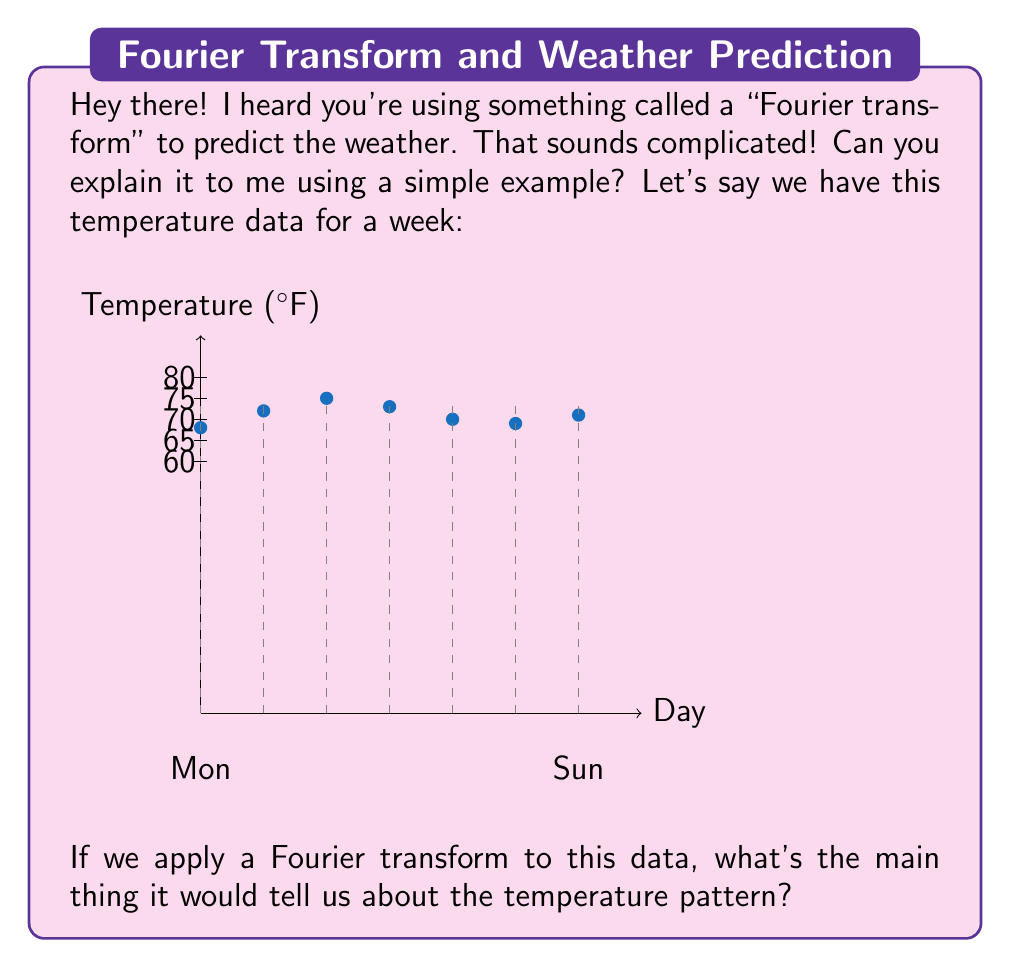Can you solve this math problem? Great question! I'd be happy to explain this in simple terms.

1) First, let's understand what the Fourier transform does. It breaks down a complex pattern into simpler, repeating waves.

2) In our temperature data, we see the temperature goes up and down over the week. The Fourier transform would look for repeating patterns in this up-and-down movement.

3) The main thing the Fourier transform would show us is the most dominant cycle in the data. In weather terms, this is often called the "period" of the pattern.

4) Looking at our data:
   Monday: 68°F
   Tuesday: 72°F
   Wednesday: 75°F
   Thursday: 73°F
   Friday: 70°F
   Saturday: 69°F
   Sunday: 71°F

5) We can see the temperature rises to a peak in the middle of the week (Wednesday) and then falls again. This suggests a weekly cycle.

6) The Fourier transform would pick up on this weekly cycle and identify it as the dominant period in the data.

7) Mathematically, if we call our temperature function $T(t)$, the Fourier transform $F(\omega)$ would be:

   $$F(\omega) = \int_{-\infty}^{\infty} T(t) e^{-i\omega t} dt$$

8) The peak in $F(\omega)$ would occur at $\omega = 2\pi/7$, corresponding to a 7-day (weekly) cycle.

So, in simple terms, the Fourier transform would tell us that the main pattern in our temperature data repeats every week.
Answer: Weekly cycle 